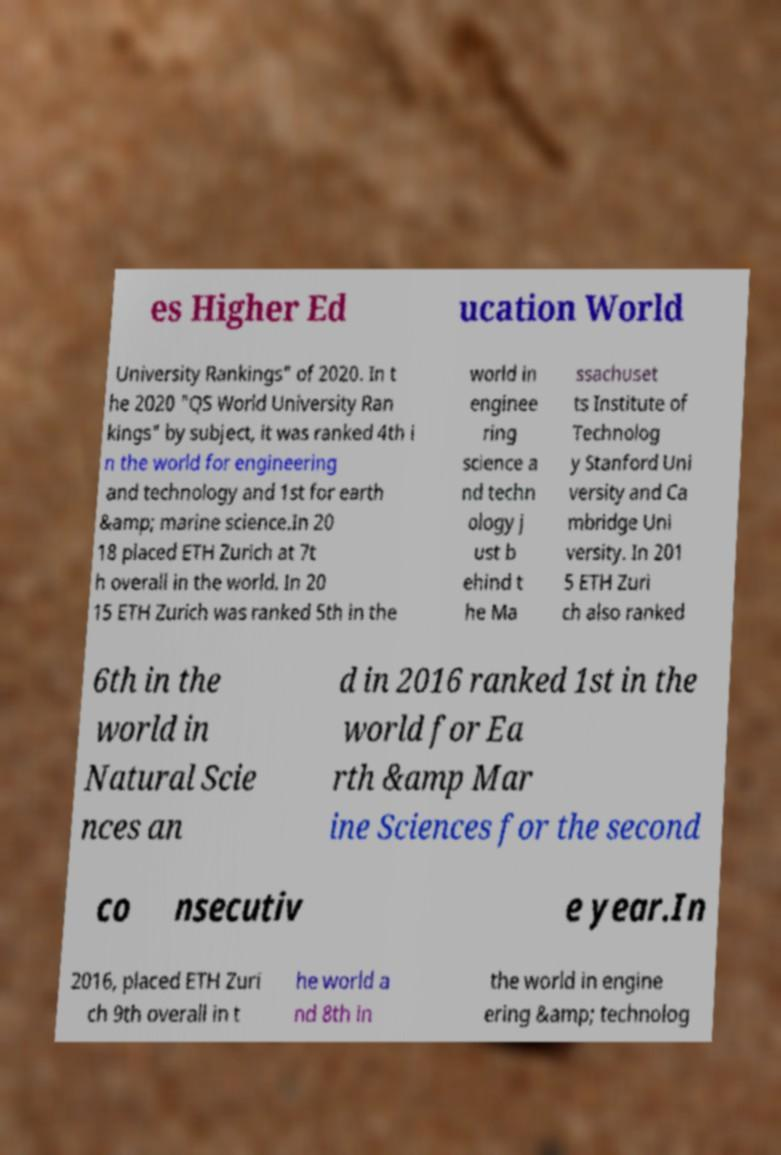Could you assist in decoding the text presented in this image and type it out clearly? es Higher Ed ucation World University Rankings" of 2020. In t he 2020 "QS World University Ran kings" by subject, it was ranked 4th i n the world for engineering and technology and 1st for earth &amp; marine science.In 20 18 placed ETH Zurich at 7t h overall in the world. In 20 15 ETH Zurich was ranked 5th in the world in enginee ring science a nd techn ology j ust b ehind t he Ma ssachuset ts Institute of Technolog y Stanford Uni versity and Ca mbridge Uni versity. In 201 5 ETH Zuri ch also ranked 6th in the world in Natural Scie nces an d in 2016 ranked 1st in the world for Ea rth &amp Mar ine Sciences for the second co nsecutiv e year.In 2016, placed ETH Zuri ch 9th overall in t he world a nd 8th in the world in engine ering &amp; technolog 